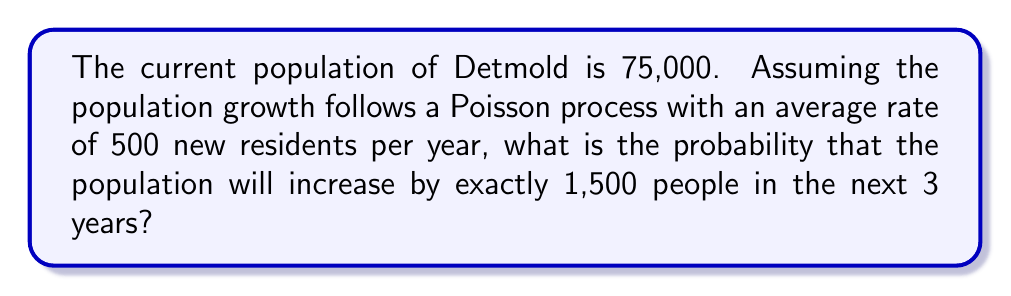Can you solve this math problem? Let's approach this step-by-step:

1) In a Poisson process, the number of events in a fixed time interval follows a Poisson distribution.

2) The Poisson distribution is characterized by its rate parameter $\lambda$, which is the average number of events in the given time interval.

3) In this case, $\lambda = 500$ people per year, and we're looking at a 3-year interval.
   So, $\lambda_{3years} = 500 \times 3 = 1500$

4) The probability of exactly $k$ events occurring in a Poisson process is given by the formula:

   $$P(X = k) = \frac{e^{-\lambda} \lambda^k}{k!}$$

   Where $e$ is Euler's number (approximately 2.71828).

5) In our case, $k = 1500$ and $\lambda = 1500$

6) Plugging these values into the formula:

   $$P(X = 1500) = \frac{e^{-1500} 1500^{1500}}{1500!}$$

7) This can be calculated using a scientific calculator or computer software:

   $$P(X = 1500) \approx 0.0103$$

Therefore, the probability of the population increasing by exactly 1,500 people in the next 3 years is approximately 0.0103 or 1.03%.
Answer: 0.0103 